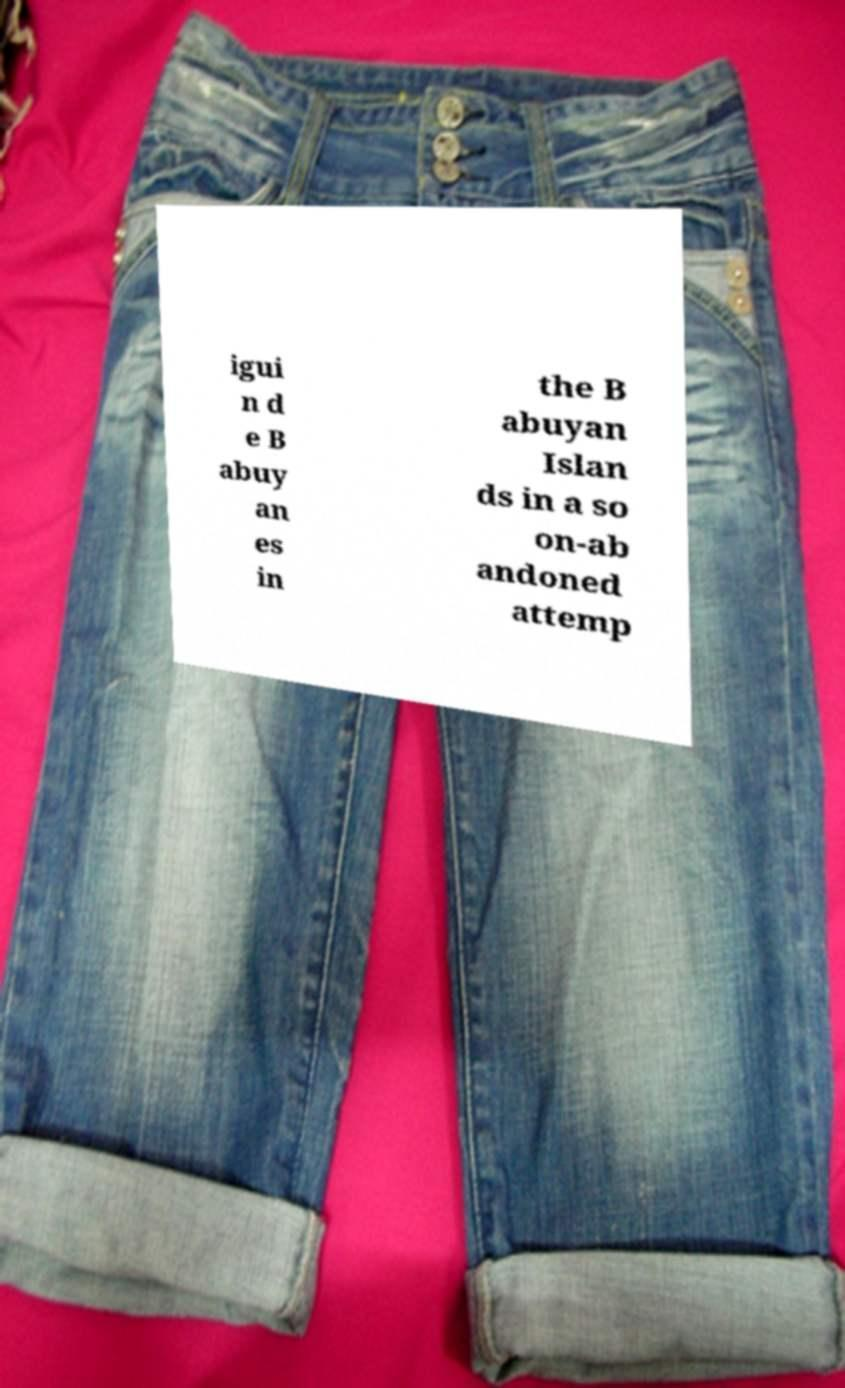Please identify and transcribe the text found in this image. igui n d e B abuy an es in the B abuyan Islan ds in a so on-ab andoned attemp 